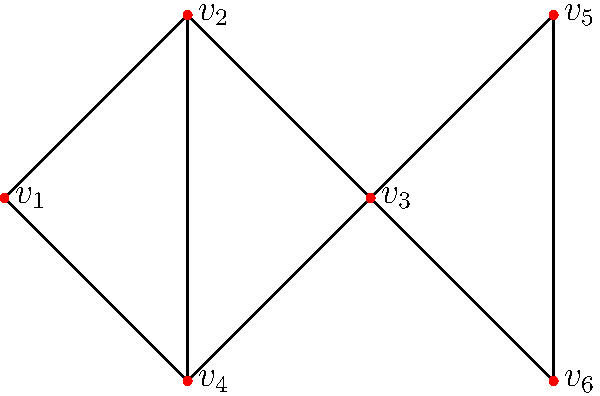Given the network graph representing a business process, which vertex has the highest betweenness centrality and should be prioritized for algorithm enhancement to improve overall efficiency? To determine the vertex with the highest betweenness centrality, we need to follow these steps:

1. Identify all shortest paths between pairs of vertices.
2. Count how many of these paths pass through each vertex.
3. Calculate the betweenness centrality for each vertex.

Step 1: Identify shortest paths
- There are 15 pairs of vertices to consider.
- Most pairs have only one shortest path, except for v1-v3 and v4-v2, which have two each.

Step 2: Count paths through each vertex
v1: 4 paths (v4-v2, v4-v5, v4-v6, v3-v2)
v2: 7 paths (v1-v5, v1-v6, v3-v5, v3-v6, v4-v5, v4-v6, v5-v6)
v3: 4 paths (v1-v2, v1-v5, v1-v6, v4-v2)
v4: 1 path (v1-v3)
v5: 0 paths
v6: 0 paths

Step 3: Calculate betweenness centrality
Betweenness centrality = (Number of shortest paths through the vertex) / (Total number of shortest paths)

v1: 4/17 ≈ 0.235
v2: 7/17 ≈ 0.412
v3: 4/17 ≈ 0.235
v4: 1/17 ≈ 0.059
v5: 0
v6: 0

Therefore, v2 has the highest betweenness centrality and should be prioritized for algorithm enhancement.
Answer: $v_2$ 